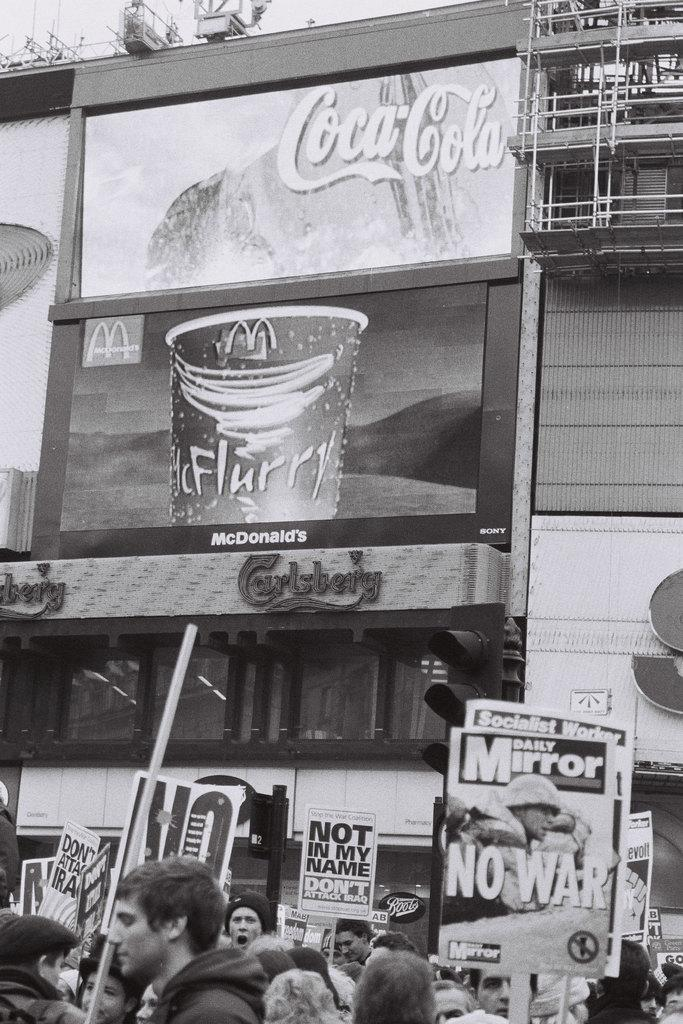Who is present in the image? There are people in the image. What are the people holding in their hands? The people are holding pluck cards. What can be seen in the distance behind the people? There are buildings visible in the background of the image. How many babies are sitting on the cherries in the image? There are no babies or cherries present in the image. What type of star can be seen shining in the sky in the image? There is no star visible in the image; only people, pluck cards, and buildings are present. 